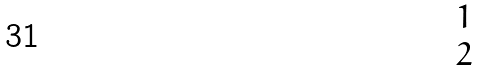Convert formula to latex. <formula><loc_0><loc_0><loc_500><loc_500>\begin{matrix} { 1 } \\ { 2 } \\ \end{matrix}</formula> 